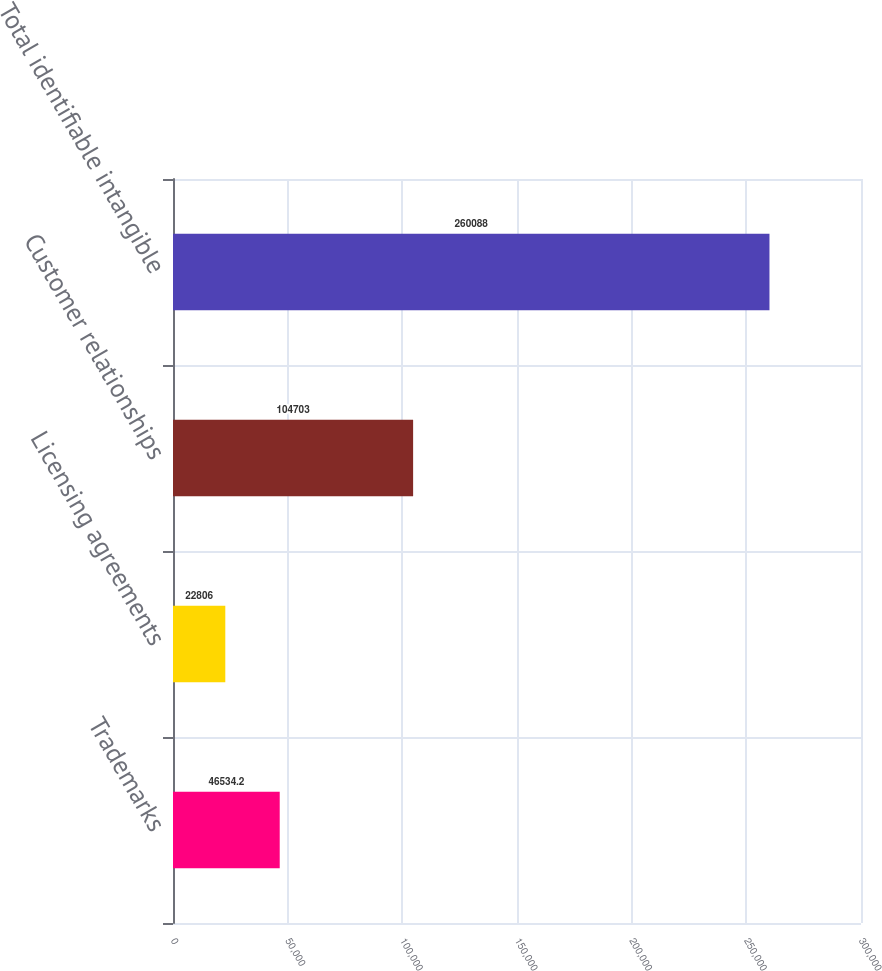Convert chart to OTSL. <chart><loc_0><loc_0><loc_500><loc_500><bar_chart><fcel>Trademarks<fcel>Licensing agreements<fcel>Customer relationships<fcel>Total identifiable intangible<nl><fcel>46534.2<fcel>22806<fcel>104703<fcel>260088<nl></chart> 